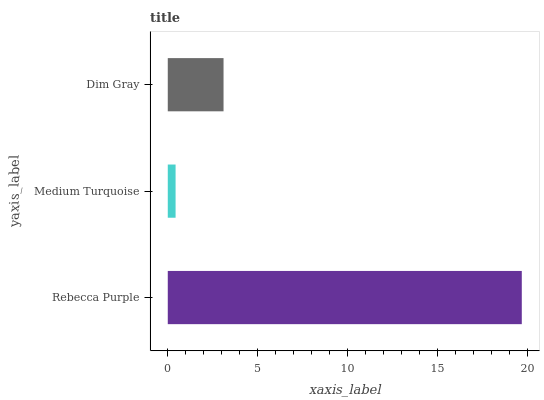Is Medium Turquoise the minimum?
Answer yes or no. Yes. Is Rebecca Purple the maximum?
Answer yes or no. Yes. Is Dim Gray the minimum?
Answer yes or no. No. Is Dim Gray the maximum?
Answer yes or no. No. Is Dim Gray greater than Medium Turquoise?
Answer yes or no. Yes. Is Medium Turquoise less than Dim Gray?
Answer yes or no. Yes. Is Medium Turquoise greater than Dim Gray?
Answer yes or no. No. Is Dim Gray less than Medium Turquoise?
Answer yes or no. No. Is Dim Gray the high median?
Answer yes or no. Yes. Is Dim Gray the low median?
Answer yes or no. Yes. Is Rebecca Purple the high median?
Answer yes or no. No. Is Rebecca Purple the low median?
Answer yes or no. No. 